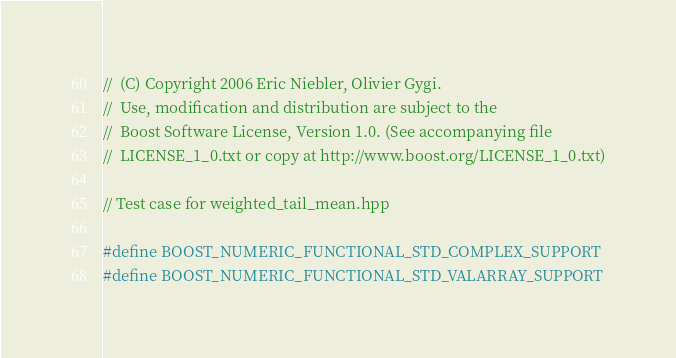<code> <loc_0><loc_0><loc_500><loc_500><_C++_>//  (C) Copyright 2006 Eric Niebler, Olivier Gygi.
//  Use, modification and distribution are subject to the
//  Boost Software License, Version 1.0. (See accompanying file
//  LICENSE_1_0.txt or copy at http://www.boost.org/LICENSE_1_0.txt)

// Test case for weighted_tail_mean.hpp

#define BOOST_NUMERIC_FUNCTIONAL_STD_COMPLEX_SUPPORT
#define BOOST_NUMERIC_FUNCTIONAL_STD_VALARRAY_SUPPORT</code> 